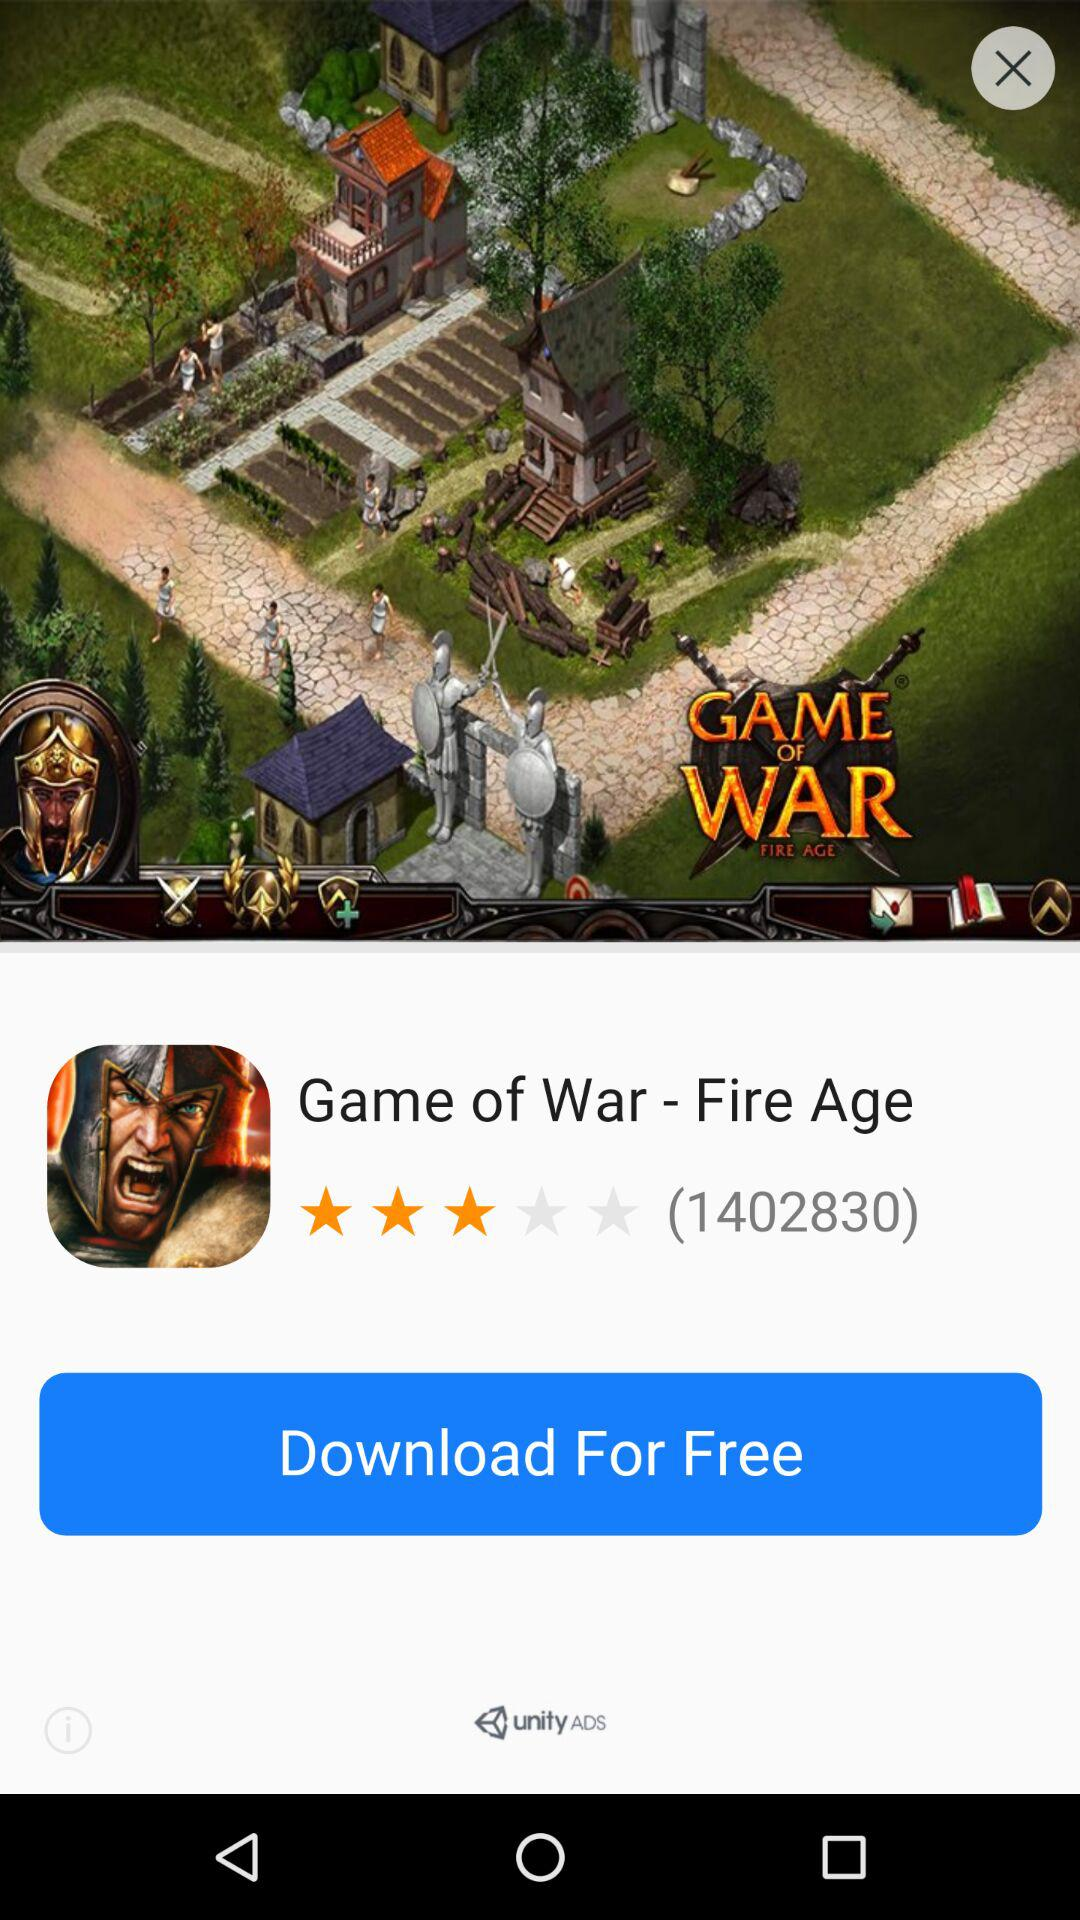How many people have rated the game? The number of people who have rated the game is 1402830. 